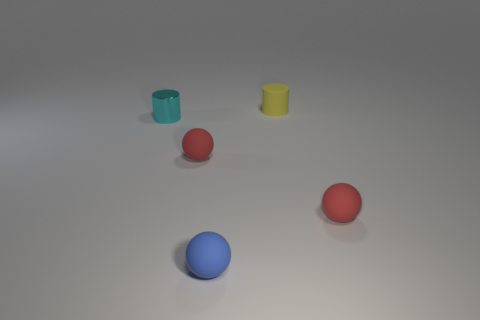Subtract all blue matte balls. How many balls are left? 2 Subtract all blue spheres. How many spheres are left? 2 Subtract 1 balls. How many balls are left? 2 Add 5 yellow rubber things. How many objects exist? 10 Subtract all balls. How many objects are left? 2 Subtract 0 yellow spheres. How many objects are left? 5 Subtract all cyan cylinders. Subtract all red spheres. How many cylinders are left? 1 Subtract all cyan blocks. How many red spheres are left? 2 Subtract all green balls. Subtract all tiny rubber objects. How many objects are left? 1 Add 5 cyan shiny things. How many cyan shiny things are left? 6 